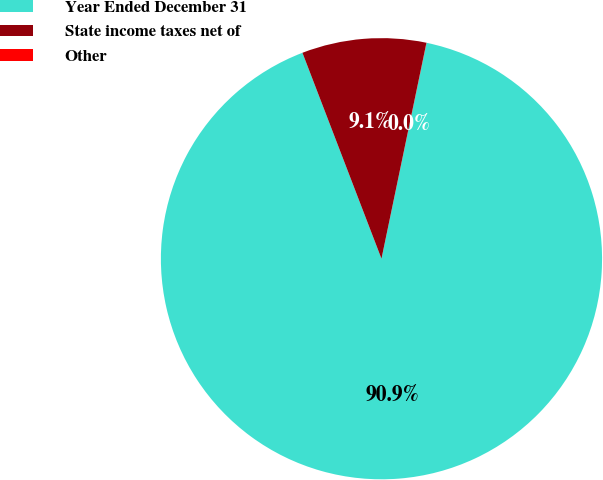Convert chart to OTSL. <chart><loc_0><loc_0><loc_500><loc_500><pie_chart><fcel>Year Ended December 31<fcel>State income taxes net of<fcel>Other<nl><fcel>90.89%<fcel>9.1%<fcel>0.01%<nl></chart> 